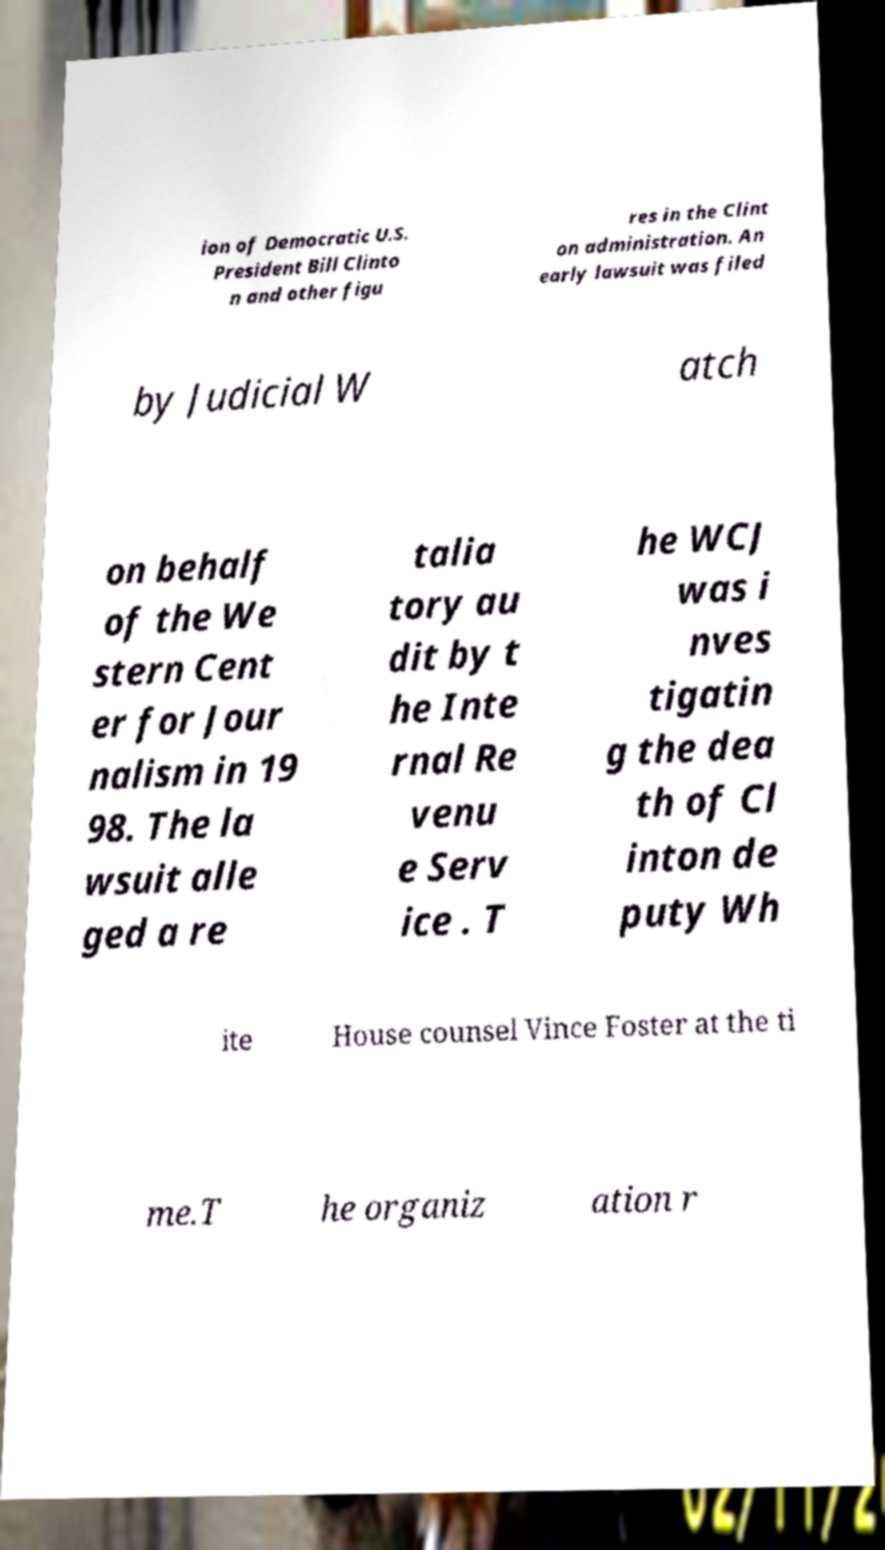I need the written content from this picture converted into text. Can you do that? ion of Democratic U.S. President Bill Clinto n and other figu res in the Clint on administration. An early lawsuit was filed by Judicial W atch on behalf of the We stern Cent er for Jour nalism in 19 98. The la wsuit alle ged a re talia tory au dit by t he Inte rnal Re venu e Serv ice . T he WCJ was i nves tigatin g the dea th of Cl inton de puty Wh ite House counsel Vince Foster at the ti me.T he organiz ation r 